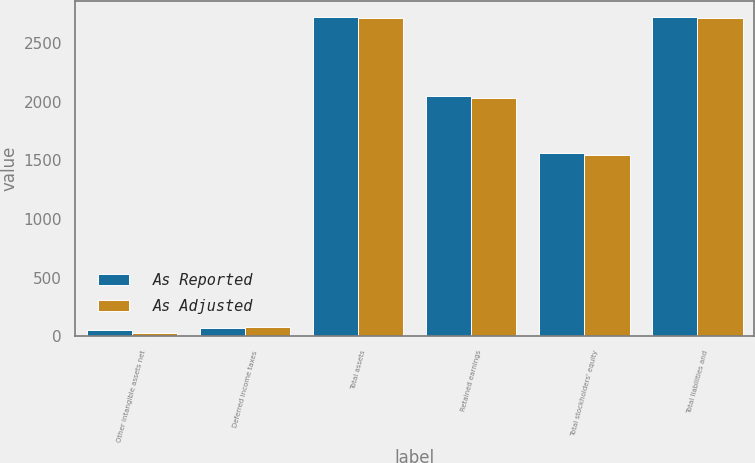Convert chart. <chart><loc_0><loc_0><loc_500><loc_500><stacked_bar_chart><ecel><fcel>Other intangible assets net<fcel>Deferred income taxes<fcel>Total assets<fcel>Retained earnings<fcel>Total stockholders' equity<fcel>Total liabilities and<nl><fcel>As Reported<fcel>57.2<fcel>70.1<fcel>2724.7<fcel>2045.6<fcel>1559.2<fcel>2724.7<nl><fcel>As Adjusted<fcel>33.5<fcel>79<fcel>2709.9<fcel>2030.8<fcel>1544.4<fcel>2709.9<nl></chart> 